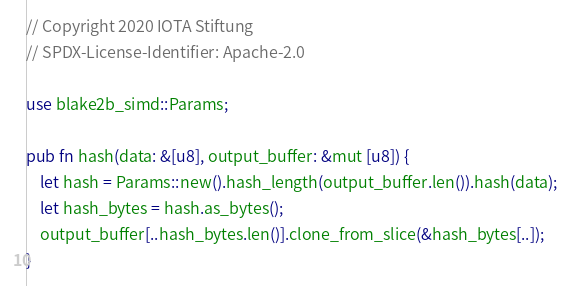Convert code to text. <code><loc_0><loc_0><loc_500><loc_500><_Rust_>// Copyright 2020 IOTA Stiftung
// SPDX-License-Identifier: Apache-2.0

use blake2b_simd::Params;

pub fn hash(data: &[u8], output_buffer: &mut [u8]) {
    let hash = Params::new().hash_length(output_buffer.len()).hash(data);
    let hash_bytes = hash.as_bytes();
    output_buffer[..hash_bytes.len()].clone_from_slice(&hash_bytes[..]);
}
</code> 